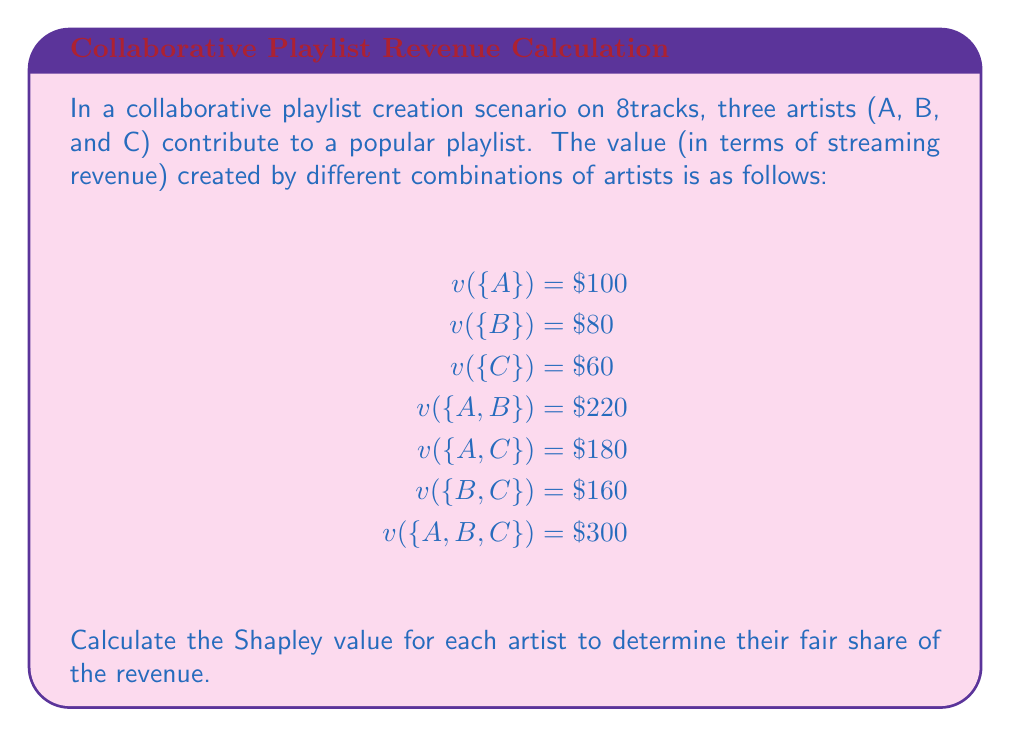Give your solution to this math problem. To calculate the Shapley value for each artist, we need to consider all possible orderings of the artists and calculate their marginal contributions. The Shapley value is then the average of these marginal contributions.

1. List all possible orderings:
   ABC, ACB, BAC, BCA, CAB, CBA

2. Calculate marginal contributions for each artist in each ordering:

   ABC: A = 100, B = 120, C = 80
   ACB: A = 100, C = 80, B = 120
   BAC: B = 80, A = 140, C = 80
   BCA: B = 80, C = 80, A = 140
   CAB: C = 60, A = 120, B = 120
   CBA: C = 60, B = 100, A = 140

3. Sum up the marginal contributions for each artist:

   A: 100 + 100 + 140 + 140 + 120 + 140 = 740
   B: 120 + 120 + 80 + 80 + 120 + 100 = 620
   C: 80 + 80 + 80 + 80 + 60 + 60 = 440

4. Calculate the Shapley value by dividing the sum by the number of orderings (6):

   Shapley value for A: $\frac{740}{6} = \$123.33$
   Shapley value for B: $\frac{620}{6} = \$103.33$
   Shapley value for C: $\frac{440}{6} = \$73.33$

5. Verify that the sum of Shapley values equals the total value:
   $123.33 + 103.33 + 73.33 = 300$, which matches $v(\{A,B,C\})$.
Answer: The Shapley values for the artists are:
Artist A: $\$123.33$
Artist B: $\$103.33$
Artist C: $\$73.33$ 